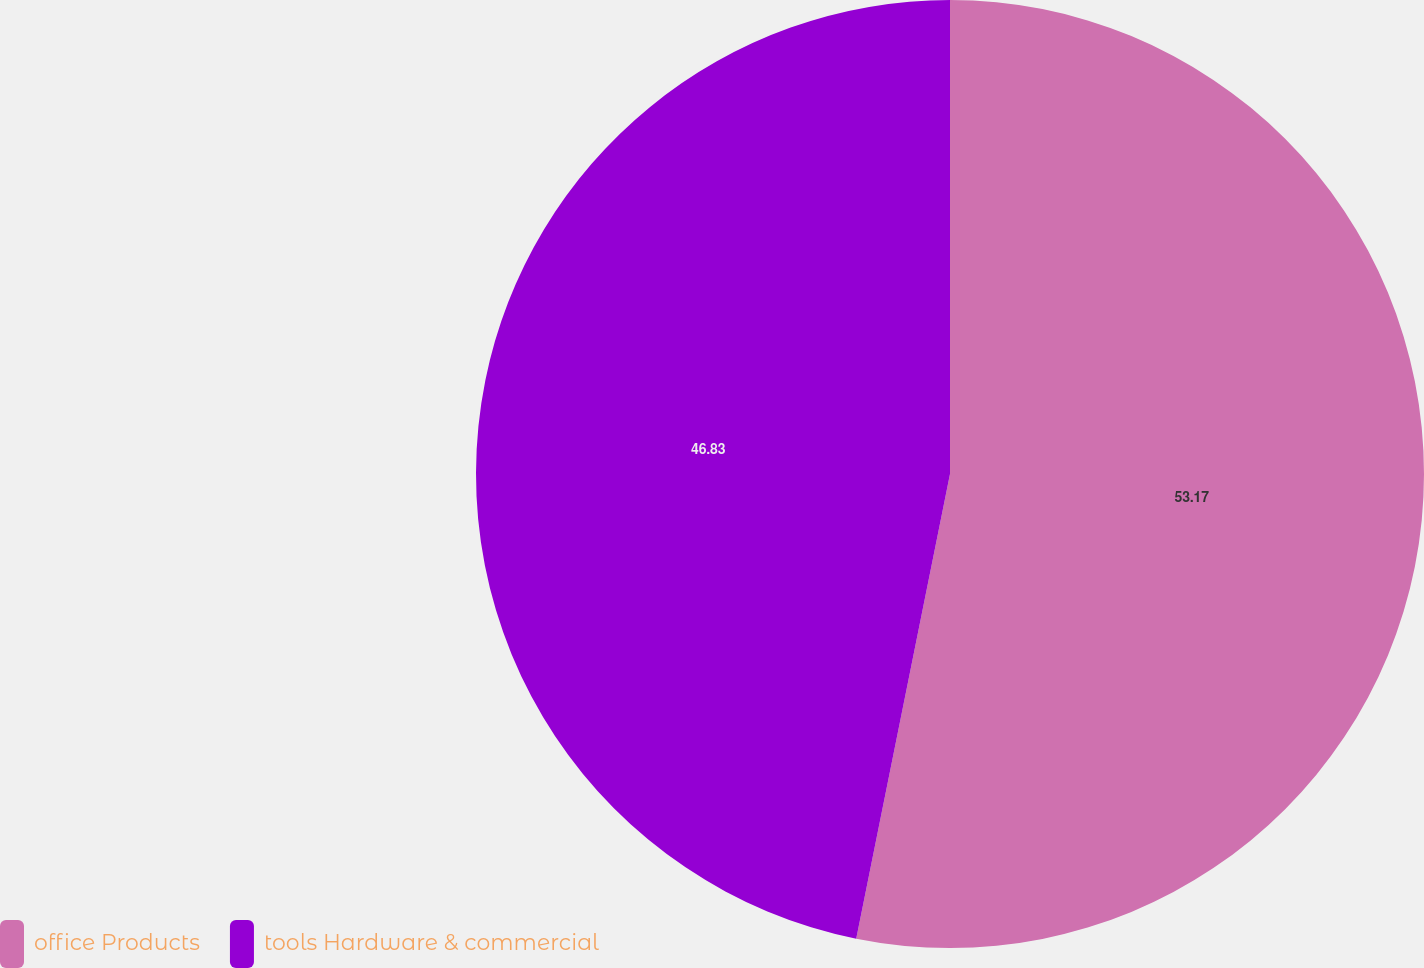Convert chart. <chart><loc_0><loc_0><loc_500><loc_500><pie_chart><fcel>office Products<fcel>tools Hardware & commercial<nl><fcel>53.17%<fcel>46.83%<nl></chart> 